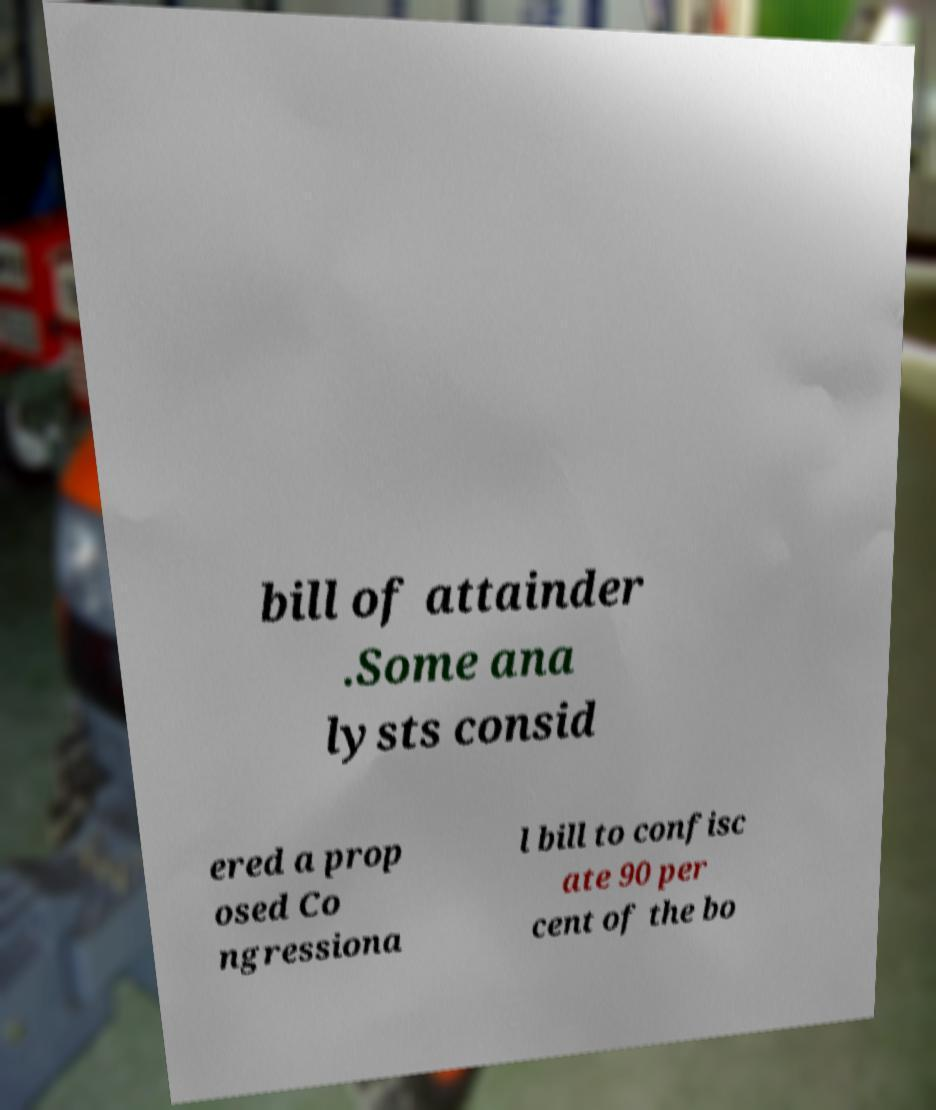What messages or text are displayed in this image? I need them in a readable, typed format. bill of attainder .Some ana lysts consid ered a prop osed Co ngressiona l bill to confisc ate 90 per cent of the bo 